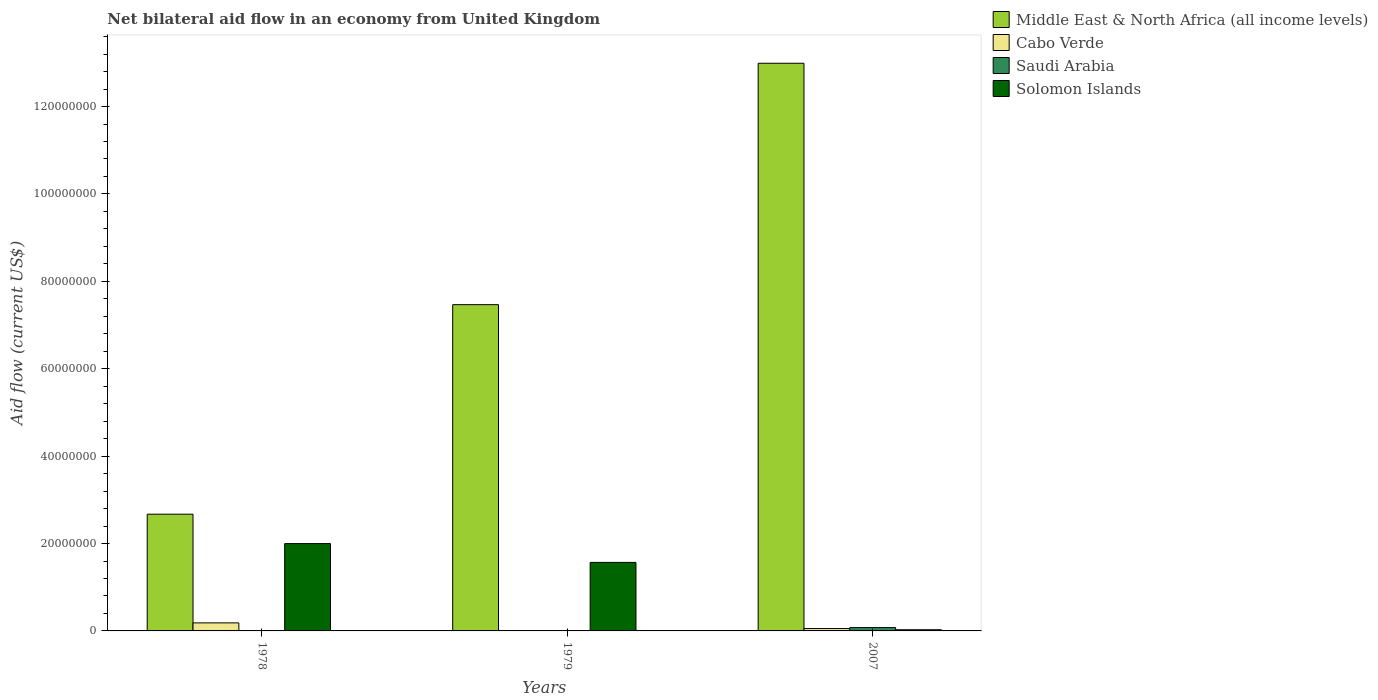How many different coloured bars are there?
Keep it short and to the point. 4. Are the number of bars per tick equal to the number of legend labels?
Your response must be concise. No. Are the number of bars on each tick of the X-axis equal?
Your answer should be very brief. No. How many bars are there on the 3rd tick from the left?
Your answer should be very brief. 4. What is the label of the 2nd group of bars from the left?
Provide a succinct answer. 1979. In how many cases, is the number of bars for a given year not equal to the number of legend labels?
Your response must be concise. 1. What is the net bilateral aid flow in Solomon Islands in 1979?
Provide a succinct answer. 1.57e+07. Across all years, what is the maximum net bilateral aid flow in Middle East & North Africa (all income levels)?
Provide a succinct answer. 1.30e+08. Across all years, what is the minimum net bilateral aid flow in Cabo Verde?
Provide a succinct answer. 0. In which year was the net bilateral aid flow in Saudi Arabia maximum?
Give a very brief answer. 2007. What is the total net bilateral aid flow in Cabo Verde in the graph?
Your answer should be compact. 2.38e+06. What is the difference between the net bilateral aid flow in Solomon Islands in 1978 and that in 1979?
Provide a short and direct response. 4.30e+06. What is the difference between the net bilateral aid flow in Cabo Verde in 1978 and the net bilateral aid flow in Solomon Islands in 1979?
Offer a very short reply. -1.38e+07. In the year 1978, what is the difference between the net bilateral aid flow in Saudi Arabia and net bilateral aid flow in Middle East & North Africa (all income levels)?
Your answer should be compact. -2.66e+07. In how many years, is the net bilateral aid flow in Solomon Islands greater than 64000000 US$?
Offer a terse response. 0. What is the difference between the highest and the second highest net bilateral aid flow in Saudi Arabia?
Give a very brief answer. 6.90e+05. What is the difference between the highest and the lowest net bilateral aid flow in Cabo Verde?
Offer a very short reply. 1.84e+06. Is it the case that in every year, the sum of the net bilateral aid flow in Saudi Arabia and net bilateral aid flow in Middle East & North Africa (all income levels) is greater than the net bilateral aid flow in Cabo Verde?
Make the answer very short. Yes. Are the values on the major ticks of Y-axis written in scientific E-notation?
Give a very brief answer. No. Does the graph contain any zero values?
Your answer should be compact. Yes. What is the title of the graph?
Your answer should be compact. Net bilateral aid flow in an economy from United Kingdom. Does "Namibia" appear as one of the legend labels in the graph?
Your answer should be very brief. No. What is the label or title of the X-axis?
Make the answer very short. Years. What is the label or title of the Y-axis?
Offer a terse response. Aid flow (current US$). What is the Aid flow (current US$) of Middle East & North Africa (all income levels) in 1978?
Provide a succinct answer. 2.67e+07. What is the Aid flow (current US$) in Cabo Verde in 1978?
Make the answer very short. 1.84e+06. What is the Aid flow (current US$) of Solomon Islands in 1978?
Ensure brevity in your answer.  2.00e+07. What is the Aid flow (current US$) in Middle East & North Africa (all income levels) in 1979?
Offer a very short reply. 7.47e+07. What is the Aid flow (current US$) in Cabo Verde in 1979?
Your answer should be very brief. 0. What is the Aid flow (current US$) of Solomon Islands in 1979?
Offer a very short reply. 1.57e+07. What is the Aid flow (current US$) of Middle East & North Africa (all income levels) in 2007?
Offer a terse response. 1.30e+08. What is the Aid flow (current US$) in Cabo Verde in 2007?
Your answer should be very brief. 5.40e+05. What is the Aid flow (current US$) of Saudi Arabia in 2007?
Keep it short and to the point. 7.60e+05. Across all years, what is the maximum Aid flow (current US$) of Middle East & North Africa (all income levels)?
Offer a very short reply. 1.30e+08. Across all years, what is the maximum Aid flow (current US$) of Cabo Verde?
Your answer should be very brief. 1.84e+06. Across all years, what is the maximum Aid flow (current US$) in Saudi Arabia?
Your response must be concise. 7.60e+05. Across all years, what is the maximum Aid flow (current US$) of Solomon Islands?
Give a very brief answer. 2.00e+07. Across all years, what is the minimum Aid flow (current US$) in Middle East & North Africa (all income levels)?
Give a very brief answer. 2.67e+07. Across all years, what is the minimum Aid flow (current US$) of Cabo Verde?
Your response must be concise. 0. Across all years, what is the minimum Aid flow (current US$) of Saudi Arabia?
Keep it short and to the point. 10000. Across all years, what is the minimum Aid flow (current US$) of Solomon Islands?
Keep it short and to the point. 2.70e+05. What is the total Aid flow (current US$) in Middle East & North Africa (all income levels) in the graph?
Your response must be concise. 2.31e+08. What is the total Aid flow (current US$) of Cabo Verde in the graph?
Provide a short and direct response. 2.38e+06. What is the total Aid flow (current US$) of Saudi Arabia in the graph?
Your answer should be compact. 8.40e+05. What is the total Aid flow (current US$) in Solomon Islands in the graph?
Provide a succinct answer. 3.59e+07. What is the difference between the Aid flow (current US$) of Middle East & North Africa (all income levels) in 1978 and that in 1979?
Ensure brevity in your answer.  -4.80e+07. What is the difference between the Aid flow (current US$) in Saudi Arabia in 1978 and that in 1979?
Your answer should be compact. 6.00e+04. What is the difference between the Aid flow (current US$) in Solomon Islands in 1978 and that in 1979?
Give a very brief answer. 4.30e+06. What is the difference between the Aid flow (current US$) of Middle East & North Africa (all income levels) in 1978 and that in 2007?
Offer a very short reply. -1.03e+08. What is the difference between the Aid flow (current US$) in Cabo Verde in 1978 and that in 2007?
Your answer should be compact. 1.30e+06. What is the difference between the Aid flow (current US$) of Saudi Arabia in 1978 and that in 2007?
Give a very brief answer. -6.90e+05. What is the difference between the Aid flow (current US$) of Solomon Islands in 1978 and that in 2007?
Offer a very short reply. 1.97e+07. What is the difference between the Aid flow (current US$) in Middle East & North Africa (all income levels) in 1979 and that in 2007?
Your answer should be compact. -5.52e+07. What is the difference between the Aid flow (current US$) of Saudi Arabia in 1979 and that in 2007?
Provide a succinct answer. -7.50e+05. What is the difference between the Aid flow (current US$) in Solomon Islands in 1979 and that in 2007?
Offer a very short reply. 1.54e+07. What is the difference between the Aid flow (current US$) in Middle East & North Africa (all income levels) in 1978 and the Aid flow (current US$) in Saudi Arabia in 1979?
Ensure brevity in your answer.  2.67e+07. What is the difference between the Aid flow (current US$) of Middle East & North Africa (all income levels) in 1978 and the Aid flow (current US$) of Solomon Islands in 1979?
Your answer should be very brief. 1.10e+07. What is the difference between the Aid flow (current US$) in Cabo Verde in 1978 and the Aid flow (current US$) in Saudi Arabia in 1979?
Make the answer very short. 1.83e+06. What is the difference between the Aid flow (current US$) of Cabo Verde in 1978 and the Aid flow (current US$) of Solomon Islands in 1979?
Your answer should be very brief. -1.38e+07. What is the difference between the Aid flow (current US$) in Saudi Arabia in 1978 and the Aid flow (current US$) in Solomon Islands in 1979?
Your response must be concise. -1.56e+07. What is the difference between the Aid flow (current US$) in Middle East & North Africa (all income levels) in 1978 and the Aid flow (current US$) in Cabo Verde in 2007?
Give a very brief answer. 2.62e+07. What is the difference between the Aid flow (current US$) of Middle East & North Africa (all income levels) in 1978 and the Aid flow (current US$) of Saudi Arabia in 2007?
Keep it short and to the point. 2.60e+07. What is the difference between the Aid flow (current US$) of Middle East & North Africa (all income levels) in 1978 and the Aid flow (current US$) of Solomon Islands in 2007?
Keep it short and to the point. 2.64e+07. What is the difference between the Aid flow (current US$) of Cabo Verde in 1978 and the Aid flow (current US$) of Saudi Arabia in 2007?
Give a very brief answer. 1.08e+06. What is the difference between the Aid flow (current US$) of Cabo Verde in 1978 and the Aid flow (current US$) of Solomon Islands in 2007?
Provide a succinct answer. 1.57e+06. What is the difference between the Aid flow (current US$) of Saudi Arabia in 1978 and the Aid flow (current US$) of Solomon Islands in 2007?
Provide a short and direct response. -2.00e+05. What is the difference between the Aid flow (current US$) of Middle East & North Africa (all income levels) in 1979 and the Aid flow (current US$) of Cabo Verde in 2007?
Offer a terse response. 7.41e+07. What is the difference between the Aid flow (current US$) in Middle East & North Africa (all income levels) in 1979 and the Aid flow (current US$) in Saudi Arabia in 2007?
Make the answer very short. 7.39e+07. What is the difference between the Aid flow (current US$) in Middle East & North Africa (all income levels) in 1979 and the Aid flow (current US$) in Solomon Islands in 2007?
Offer a terse response. 7.44e+07. What is the difference between the Aid flow (current US$) in Saudi Arabia in 1979 and the Aid flow (current US$) in Solomon Islands in 2007?
Keep it short and to the point. -2.60e+05. What is the average Aid flow (current US$) in Middle East & North Africa (all income levels) per year?
Your response must be concise. 7.71e+07. What is the average Aid flow (current US$) in Cabo Verde per year?
Provide a succinct answer. 7.93e+05. What is the average Aid flow (current US$) of Solomon Islands per year?
Make the answer very short. 1.20e+07. In the year 1978, what is the difference between the Aid flow (current US$) in Middle East & North Africa (all income levels) and Aid flow (current US$) in Cabo Verde?
Your answer should be compact. 2.49e+07. In the year 1978, what is the difference between the Aid flow (current US$) of Middle East & North Africa (all income levels) and Aid flow (current US$) of Saudi Arabia?
Offer a terse response. 2.66e+07. In the year 1978, what is the difference between the Aid flow (current US$) of Middle East & North Africa (all income levels) and Aid flow (current US$) of Solomon Islands?
Your response must be concise. 6.73e+06. In the year 1978, what is the difference between the Aid flow (current US$) in Cabo Verde and Aid flow (current US$) in Saudi Arabia?
Keep it short and to the point. 1.77e+06. In the year 1978, what is the difference between the Aid flow (current US$) of Cabo Verde and Aid flow (current US$) of Solomon Islands?
Keep it short and to the point. -1.81e+07. In the year 1978, what is the difference between the Aid flow (current US$) of Saudi Arabia and Aid flow (current US$) of Solomon Islands?
Provide a succinct answer. -1.99e+07. In the year 1979, what is the difference between the Aid flow (current US$) in Middle East & North Africa (all income levels) and Aid flow (current US$) in Saudi Arabia?
Your answer should be compact. 7.46e+07. In the year 1979, what is the difference between the Aid flow (current US$) in Middle East & North Africa (all income levels) and Aid flow (current US$) in Solomon Islands?
Ensure brevity in your answer.  5.90e+07. In the year 1979, what is the difference between the Aid flow (current US$) in Saudi Arabia and Aid flow (current US$) in Solomon Islands?
Your response must be concise. -1.57e+07. In the year 2007, what is the difference between the Aid flow (current US$) of Middle East & North Africa (all income levels) and Aid flow (current US$) of Cabo Verde?
Give a very brief answer. 1.29e+08. In the year 2007, what is the difference between the Aid flow (current US$) in Middle East & North Africa (all income levels) and Aid flow (current US$) in Saudi Arabia?
Provide a succinct answer. 1.29e+08. In the year 2007, what is the difference between the Aid flow (current US$) in Middle East & North Africa (all income levels) and Aid flow (current US$) in Solomon Islands?
Provide a short and direct response. 1.30e+08. In the year 2007, what is the difference between the Aid flow (current US$) in Cabo Verde and Aid flow (current US$) in Saudi Arabia?
Offer a terse response. -2.20e+05. In the year 2007, what is the difference between the Aid flow (current US$) in Saudi Arabia and Aid flow (current US$) in Solomon Islands?
Your response must be concise. 4.90e+05. What is the ratio of the Aid flow (current US$) of Middle East & North Africa (all income levels) in 1978 to that in 1979?
Ensure brevity in your answer.  0.36. What is the ratio of the Aid flow (current US$) of Solomon Islands in 1978 to that in 1979?
Your answer should be compact. 1.27. What is the ratio of the Aid flow (current US$) of Middle East & North Africa (all income levels) in 1978 to that in 2007?
Ensure brevity in your answer.  0.21. What is the ratio of the Aid flow (current US$) in Cabo Verde in 1978 to that in 2007?
Offer a terse response. 3.41. What is the ratio of the Aid flow (current US$) of Saudi Arabia in 1978 to that in 2007?
Provide a succinct answer. 0.09. What is the ratio of the Aid flow (current US$) of Solomon Islands in 1978 to that in 2007?
Your response must be concise. 74. What is the ratio of the Aid flow (current US$) in Middle East & North Africa (all income levels) in 1979 to that in 2007?
Make the answer very short. 0.57. What is the ratio of the Aid flow (current US$) in Saudi Arabia in 1979 to that in 2007?
Provide a short and direct response. 0.01. What is the ratio of the Aid flow (current US$) in Solomon Islands in 1979 to that in 2007?
Provide a short and direct response. 58.07. What is the difference between the highest and the second highest Aid flow (current US$) of Middle East & North Africa (all income levels)?
Offer a very short reply. 5.52e+07. What is the difference between the highest and the second highest Aid flow (current US$) in Saudi Arabia?
Your response must be concise. 6.90e+05. What is the difference between the highest and the second highest Aid flow (current US$) of Solomon Islands?
Your response must be concise. 4.30e+06. What is the difference between the highest and the lowest Aid flow (current US$) in Middle East & North Africa (all income levels)?
Give a very brief answer. 1.03e+08. What is the difference between the highest and the lowest Aid flow (current US$) in Cabo Verde?
Ensure brevity in your answer.  1.84e+06. What is the difference between the highest and the lowest Aid flow (current US$) of Saudi Arabia?
Make the answer very short. 7.50e+05. What is the difference between the highest and the lowest Aid flow (current US$) in Solomon Islands?
Make the answer very short. 1.97e+07. 